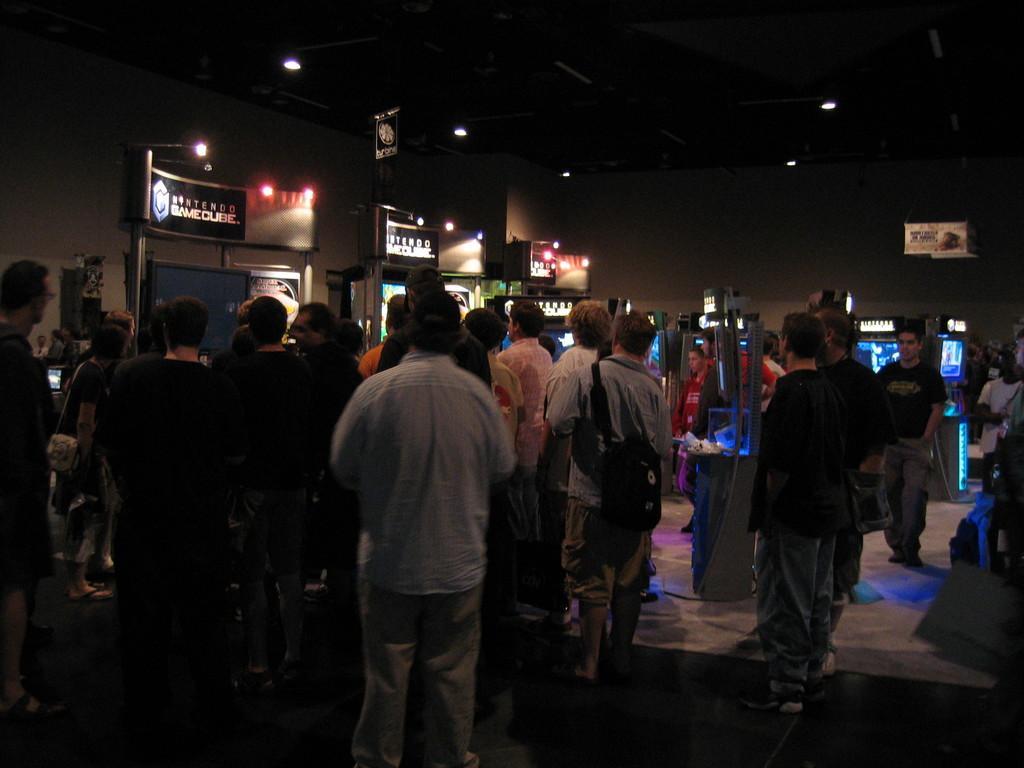In one or two sentences, can you explain what this image depicts? In this picture we can see some people standing, in the background there is a wall, we can see some screens here, there are some lights at the top of the picture. 